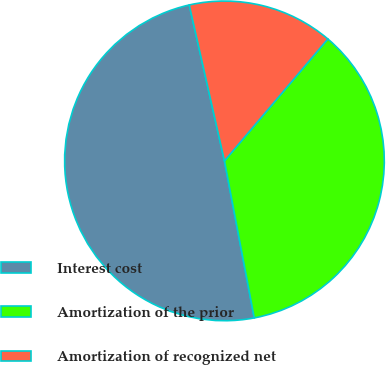<chart> <loc_0><loc_0><loc_500><loc_500><pie_chart><fcel>Interest cost<fcel>Amortization of the prior<fcel>Amortization of recognized net<nl><fcel>49.45%<fcel>35.82%<fcel>14.73%<nl></chart> 